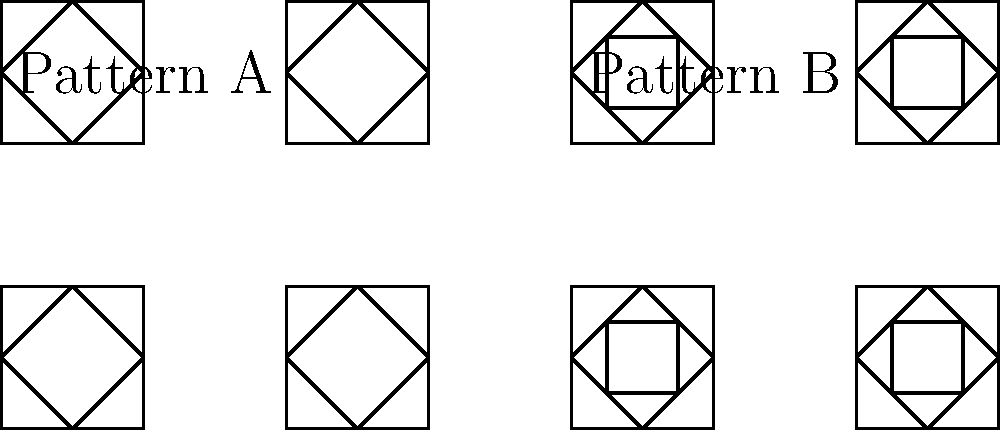Compare the two Arabic architectural patterns shown above. Which pattern is more complex and why? To determine which pattern is more complex, we need to analyze both patterns step-by-step:

1. Pattern A:
   - Contains a square outer shape
   - Has a diamond shape inside the square
   - Total of 2 distinct geometric shapes

2. Pattern B:
   - Contains a square outer shape
   - Has a diamond shape inside the square
   - Additionally, has a smaller square inside the diamond
   - Total of 3 distinct geometric shapes

3. Complexity comparison:
   - Pattern B has more geometric elements (3 vs 2)
   - Pattern B creates more intricate intersections between shapes
   - Pattern B has a hierarchical structure (square within diamond within square)

4. Islamic geometric patterns:
   - Often based on repetitive geometric forms
   - Complexity increases with the number of layers and intersections

5. Architectural significance:
   - More complex patterns often require greater skill to design and implement
   - Complexity in Islamic patterns often symbolizes the infinite nature of Allah

Based on this analysis, Pattern B is more complex due to its additional geometric element, more intricate intersections, and hierarchical structure.
Answer: Pattern B is more complex, featuring 3 geometric shapes with more intricate intersections. 